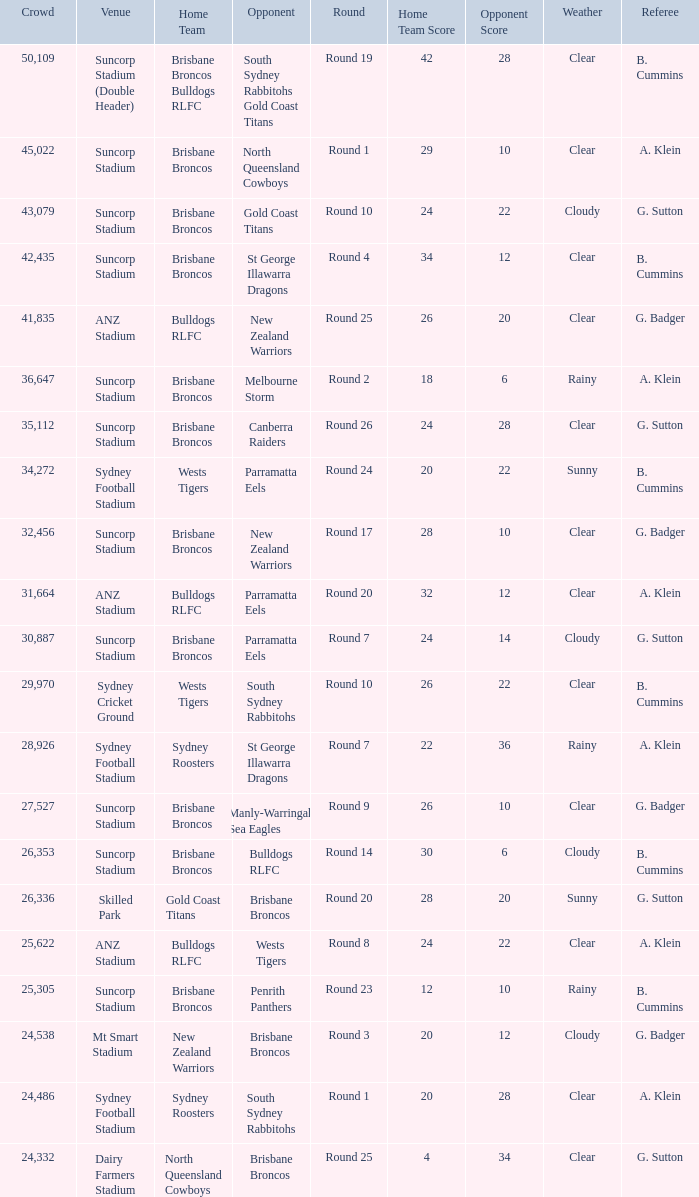What was the attendance at Round 9? 1.0. 